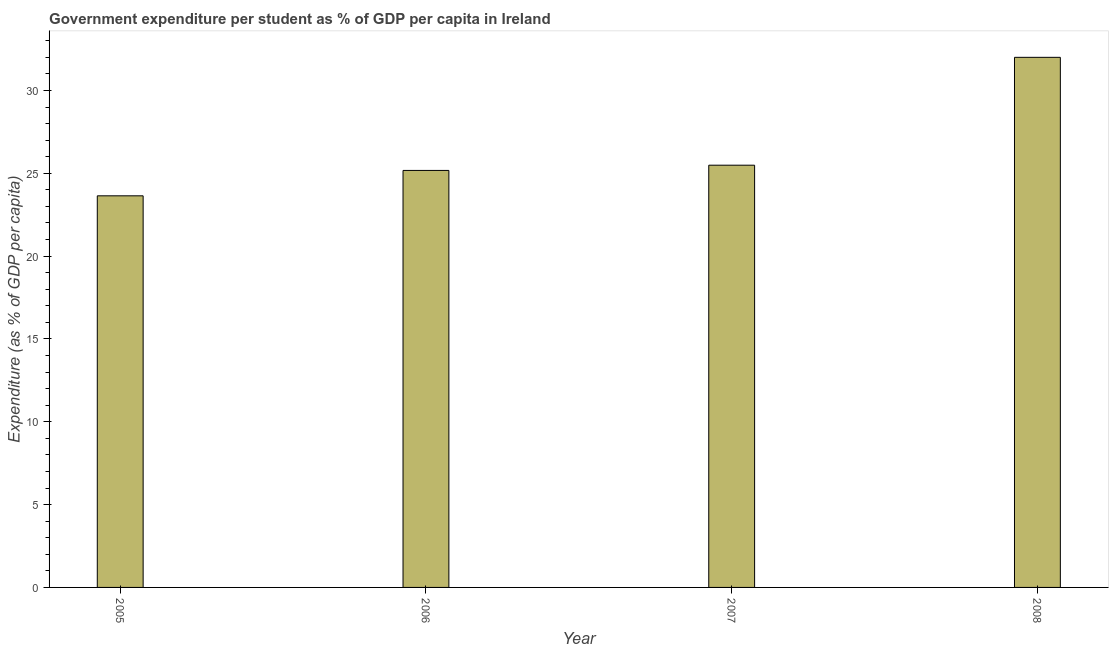What is the title of the graph?
Provide a succinct answer. Government expenditure per student as % of GDP per capita in Ireland. What is the label or title of the X-axis?
Provide a succinct answer. Year. What is the label or title of the Y-axis?
Ensure brevity in your answer.  Expenditure (as % of GDP per capita). What is the government expenditure per student in 2008?
Keep it short and to the point. 32. Across all years, what is the maximum government expenditure per student?
Keep it short and to the point. 32. Across all years, what is the minimum government expenditure per student?
Offer a terse response. 23.64. In which year was the government expenditure per student maximum?
Give a very brief answer. 2008. What is the sum of the government expenditure per student?
Offer a very short reply. 106.3. What is the difference between the government expenditure per student in 2005 and 2006?
Provide a succinct answer. -1.53. What is the average government expenditure per student per year?
Provide a succinct answer. 26.57. What is the median government expenditure per student?
Make the answer very short. 25.33. What is the ratio of the government expenditure per student in 2005 to that in 2006?
Make the answer very short. 0.94. Is the government expenditure per student in 2005 less than that in 2006?
Provide a short and direct response. Yes. Is the difference between the government expenditure per student in 2006 and 2008 greater than the difference between any two years?
Your answer should be compact. No. What is the difference between the highest and the second highest government expenditure per student?
Your answer should be very brief. 6.51. Is the sum of the government expenditure per student in 2006 and 2008 greater than the maximum government expenditure per student across all years?
Offer a very short reply. Yes. What is the difference between the highest and the lowest government expenditure per student?
Your answer should be compact. 8.36. How many bars are there?
Provide a short and direct response. 4. Are all the bars in the graph horizontal?
Offer a very short reply. No. What is the difference between two consecutive major ticks on the Y-axis?
Offer a terse response. 5. Are the values on the major ticks of Y-axis written in scientific E-notation?
Give a very brief answer. No. What is the Expenditure (as % of GDP per capita) in 2005?
Keep it short and to the point. 23.64. What is the Expenditure (as % of GDP per capita) of 2006?
Offer a very short reply. 25.17. What is the Expenditure (as % of GDP per capita) in 2007?
Provide a succinct answer. 25.49. What is the Expenditure (as % of GDP per capita) in 2008?
Keep it short and to the point. 32. What is the difference between the Expenditure (as % of GDP per capita) in 2005 and 2006?
Give a very brief answer. -1.53. What is the difference between the Expenditure (as % of GDP per capita) in 2005 and 2007?
Provide a succinct answer. -1.85. What is the difference between the Expenditure (as % of GDP per capita) in 2005 and 2008?
Offer a very short reply. -8.36. What is the difference between the Expenditure (as % of GDP per capita) in 2006 and 2007?
Offer a very short reply. -0.32. What is the difference between the Expenditure (as % of GDP per capita) in 2006 and 2008?
Offer a terse response. -6.83. What is the difference between the Expenditure (as % of GDP per capita) in 2007 and 2008?
Your answer should be compact. -6.51. What is the ratio of the Expenditure (as % of GDP per capita) in 2005 to that in 2006?
Ensure brevity in your answer.  0.94. What is the ratio of the Expenditure (as % of GDP per capita) in 2005 to that in 2007?
Your answer should be very brief. 0.93. What is the ratio of the Expenditure (as % of GDP per capita) in 2005 to that in 2008?
Your answer should be compact. 0.74. What is the ratio of the Expenditure (as % of GDP per capita) in 2006 to that in 2008?
Make the answer very short. 0.79. What is the ratio of the Expenditure (as % of GDP per capita) in 2007 to that in 2008?
Provide a short and direct response. 0.8. 